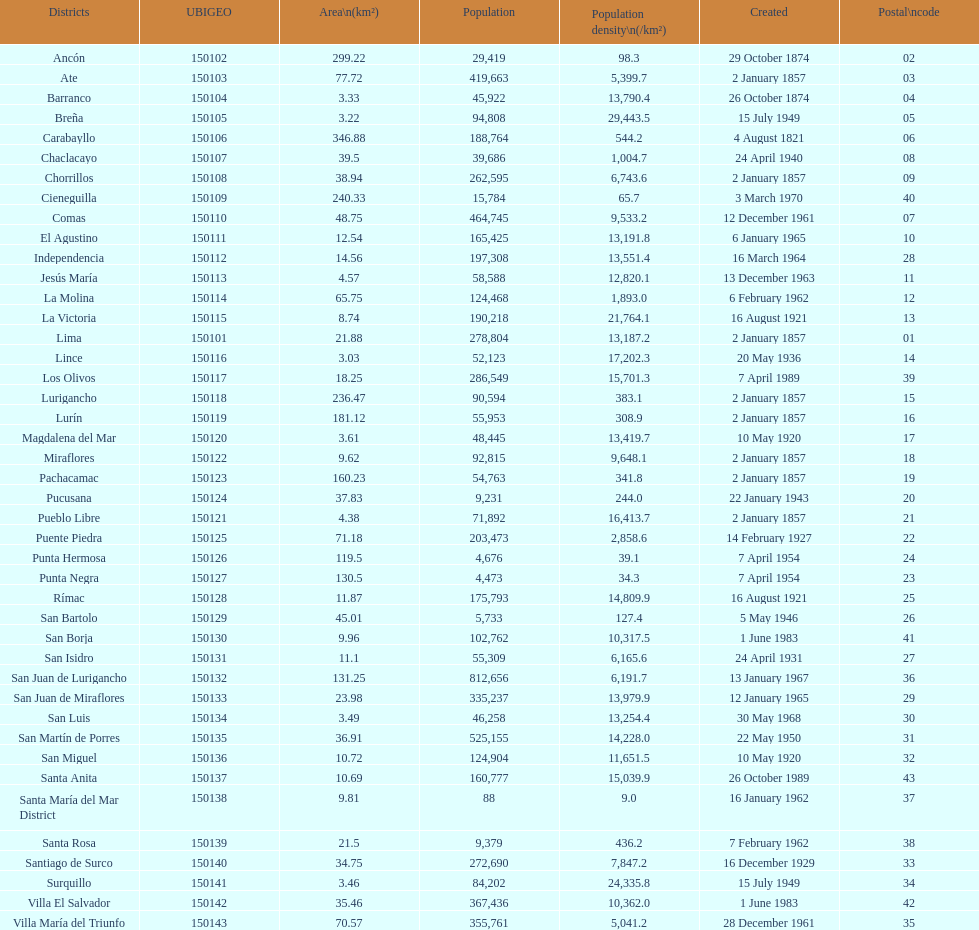What is the overall count of lima's districts? 43. 